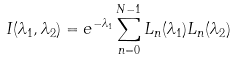<formula> <loc_0><loc_0><loc_500><loc_500>I ( \lambda _ { 1 } , \lambda _ { 2 } ) = e ^ { - \lambda _ { 1 } } \sum _ { n = 0 } ^ { N - 1 } L _ { n } ( \lambda _ { 1 } ) L _ { n } ( \lambda _ { 2 } )</formula> 